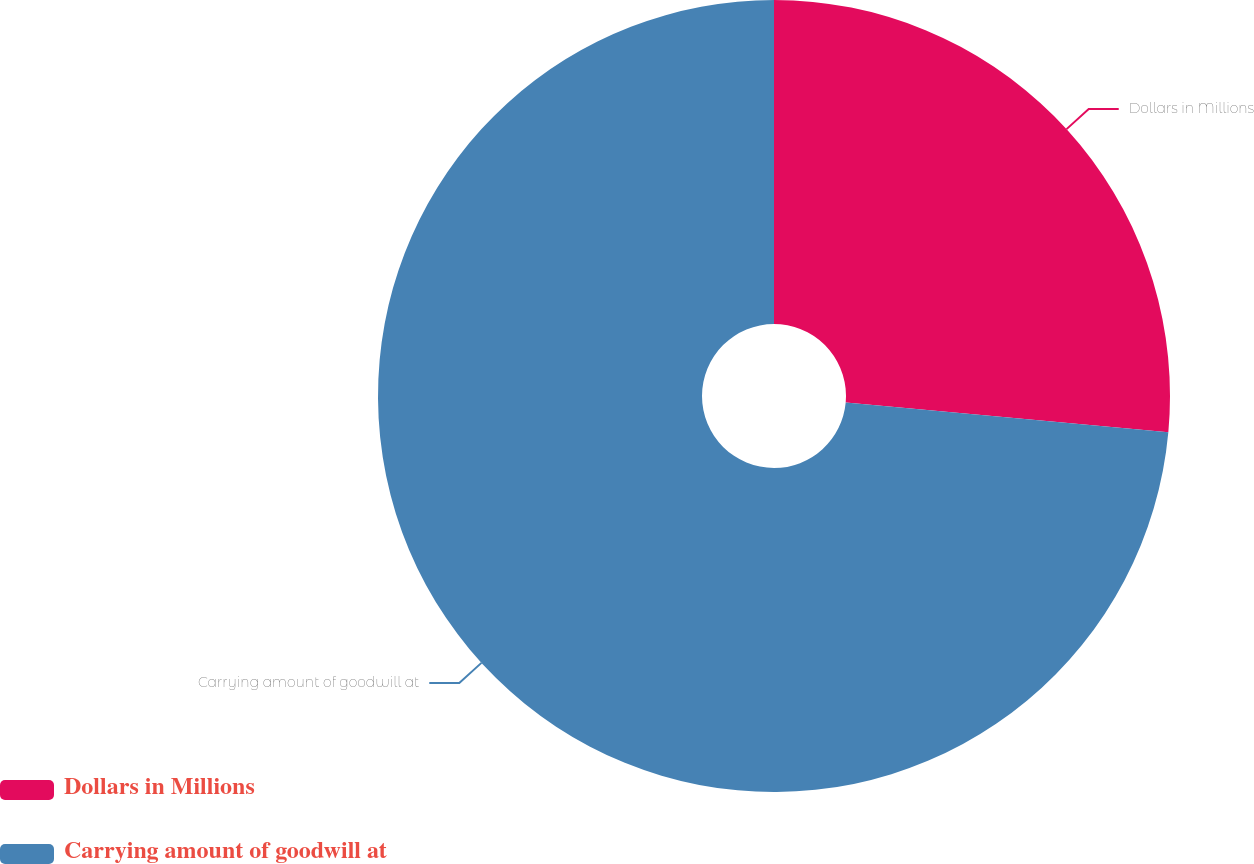<chart> <loc_0><loc_0><loc_500><loc_500><pie_chart><fcel>Dollars in Millions<fcel>Carrying amount of goodwill at<nl><fcel>26.46%<fcel>73.54%<nl></chart> 